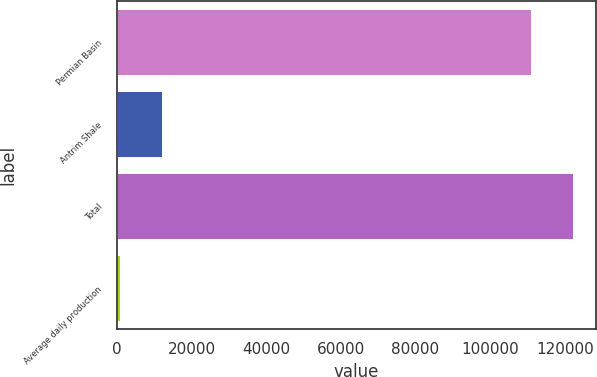Convert chart. <chart><loc_0><loc_0><loc_500><loc_500><bar_chart><fcel>Permian Basin<fcel>Antrim Shale<fcel>Total<fcel>Average daily production<nl><fcel>110973<fcel>12071.9<fcel>122300<fcel>745<nl></chart> 